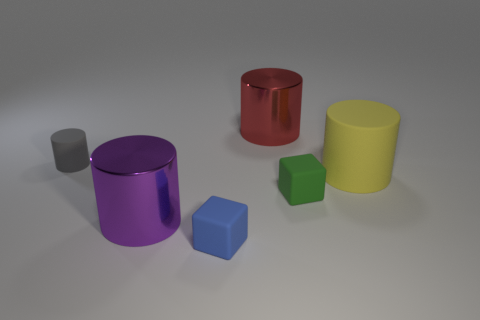Add 4 tiny metallic cylinders. How many objects exist? 10 Subtract all cubes. How many objects are left? 4 Subtract 1 yellow cylinders. How many objects are left? 5 Subtract all brown metal blocks. Subtract all large metal objects. How many objects are left? 4 Add 3 big purple shiny objects. How many big purple shiny objects are left? 4 Add 4 small matte cylinders. How many small matte cylinders exist? 5 